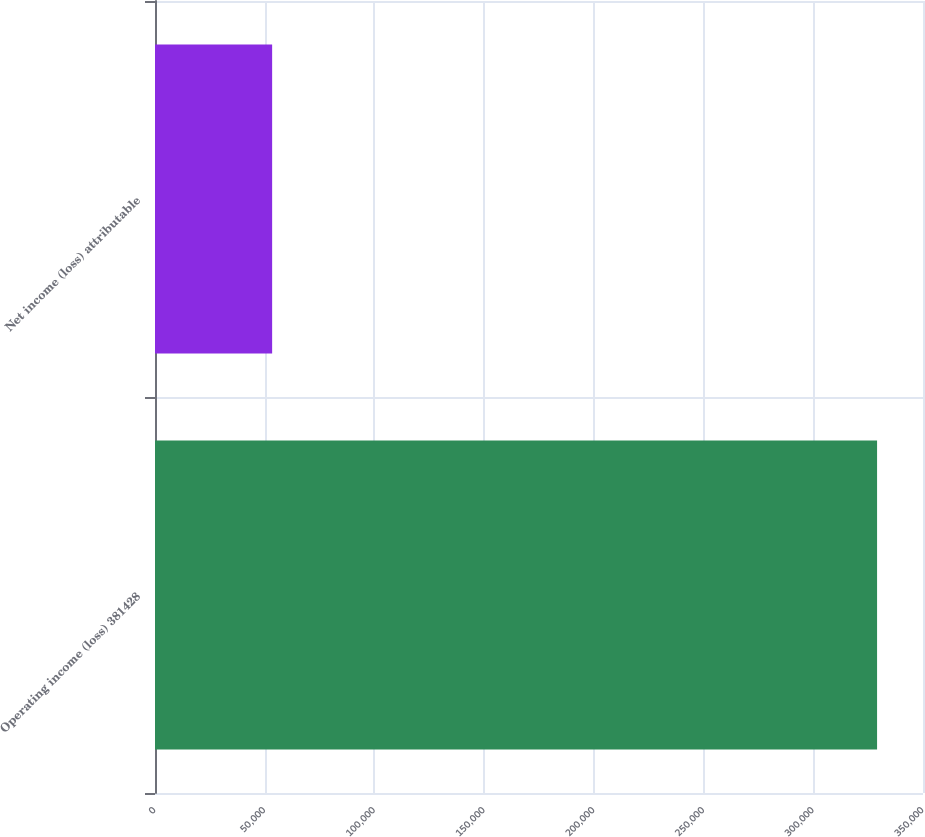Convert chart to OTSL. <chart><loc_0><loc_0><loc_500><loc_500><bar_chart><fcel>Operating income (loss) 381428<fcel>Net income (loss) attributable<nl><fcel>329070<fcel>53382<nl></chart> 